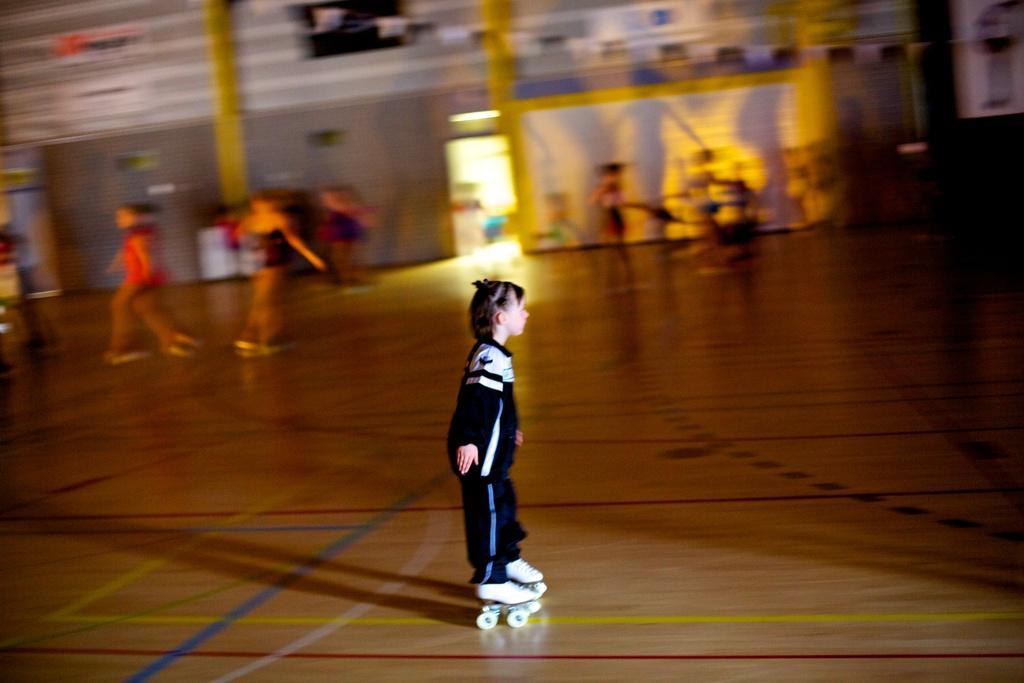Please provide a concise description of this image. In the image there is a girl in navy blue dress skating on the wooden floor, this is clicked inside a stadium, in the back there are many persons visible and followed by a wall in the background. 